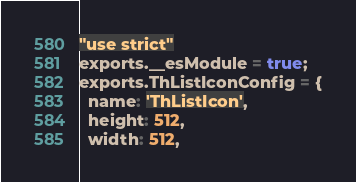Convert code to text. <code><loc_0><loc_0><loc_500><loc_500><_JavaScript_>"use strict"
exports.__esModule = true;
exports.ThListIconConfig = {
  name: 'ThListIcon',
  height: 512,
  width: 512,</code> 